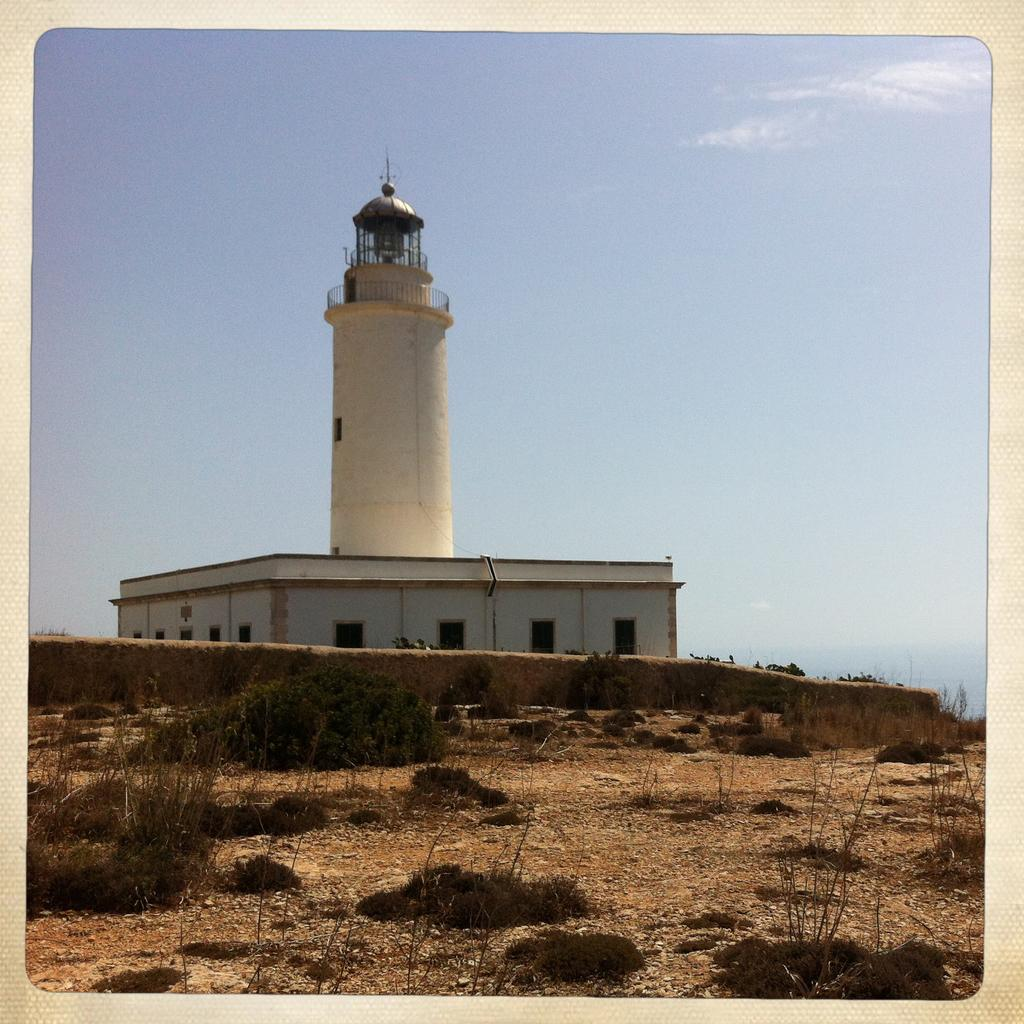What is the main structure in the image? There is a lighthouse in the image. What other type of building can be seen in the image? There is a building in the image. What type of vegetation is present in the image? There are plants and grass in the image. What type of barrier is visible in the image? There is a wall in the image. What type of ground surface is present in the image? Soil is present in the image. What is visible in the background of the image? The sky is visible in the background of the image. How is the image framed? The image has borders. What type of noise can be heard coming from the lighthouse in the image? There is no indication of sound in the image, so it is not possible to determine what noise might be heard. 